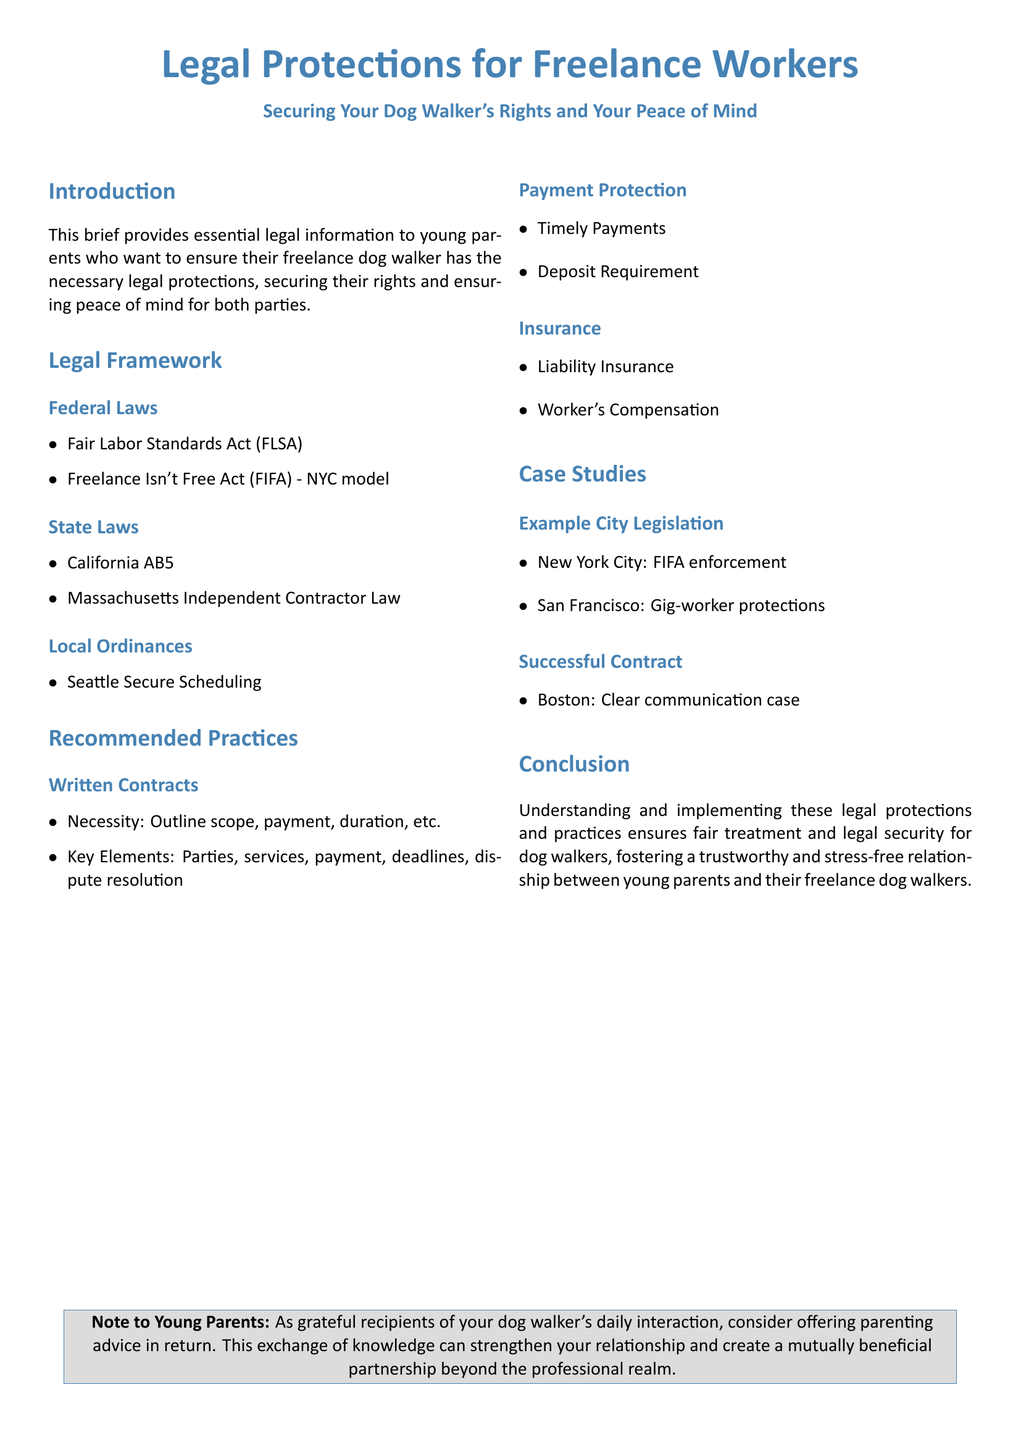What does FLSA stand for? FLSA stands for Fair Labor Standards Act, which is a federal law mentioned in the document.
Answer: Fair Labor Standards Act What is the abbreviation for the Freelance Isn't Free Act? The abbreviation for the Freelance Isn't Free Act is FIFA, as noted in the document.
Answer: FIFA Which city is specifically mentioned for enforcing FIFA? The document states that New York City is the location for FIFA enforcement.
Answer: New York City What type of insurance is recommended for dog walkers? The document recommends liability insurance as part of the best practices for dog walkers.
Answer: Liability Insurance What should written contracts outline? Written contracts should outline scope, payment, duration, etc., as indicated in the recommended practices section.
Answer: Scope, payment, duration What does the acronym AB5 relate to? AB5 refers to a California state law concerning independent contractors, as detailed in the legal framework section.
Answer: California AB5 What can strengthen the relationship between parents and dog walkers? The document suggests that offering parenting advice in return can strengthen the relationship between parents and their dog walkers.
Answer: Parenting advice What is the goal of this legal brief? The goal of the legal brief is to ensure fair treatment and legal security for dog walkers.
Answer: Fair treatment and legal security Which city's legislation is cited for gig-worker protections? San Francisco is cited in the document as an example city for gig-worker protections.
Answer: San Francisco 